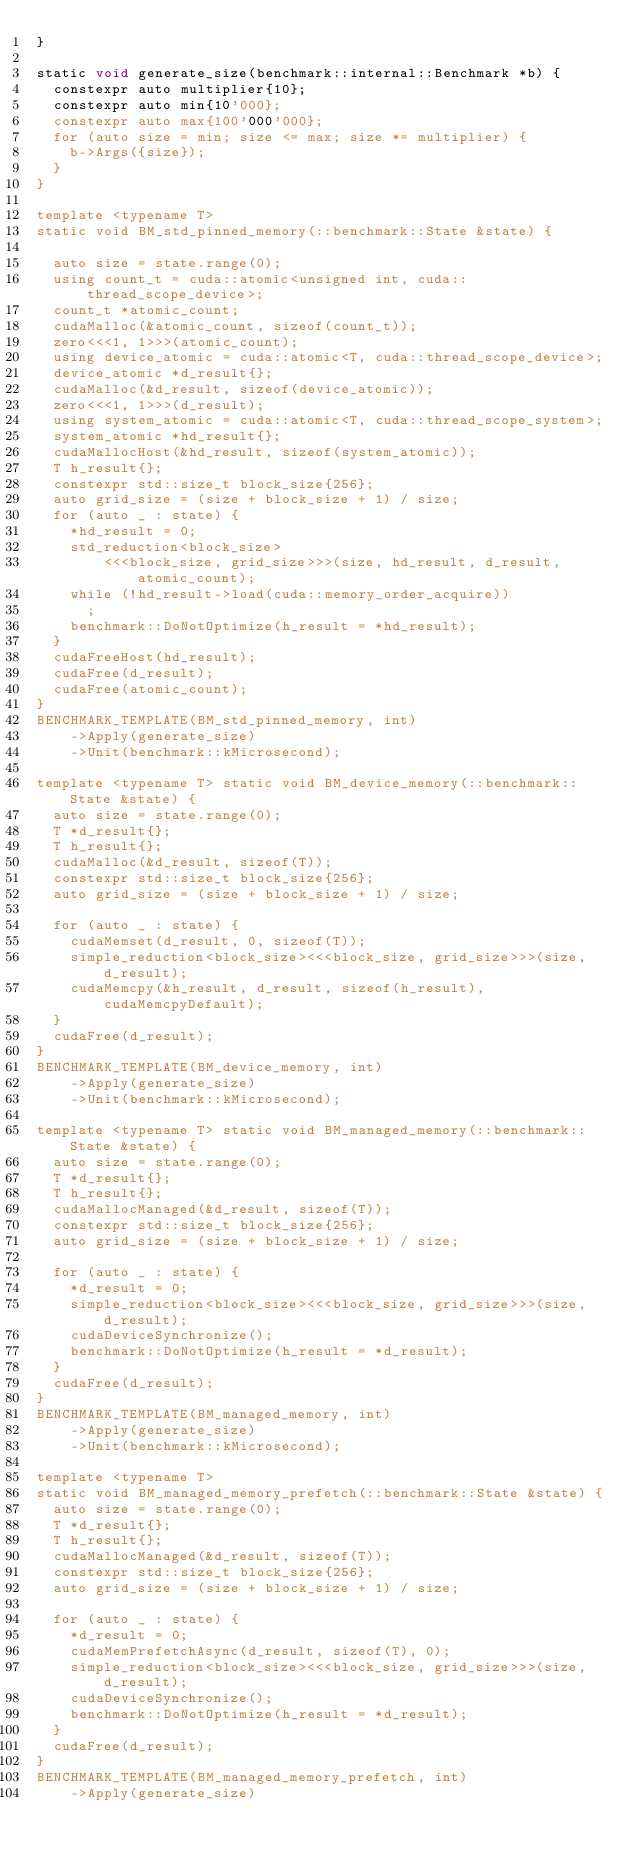Convert code to text. <code><loc_0><loc_0><loc_500><loc_500><_Cuda_>}

static void generate_size(benchmark::internal::Benchmark *b) {
  constexpr auto multiplier{10};
  constexpr auto min{10'000};
  constexpr auto max{100'000'000};
  for (auto size = min; size <= max; size *= multiplier) {
    b->Args({size});
  }
}

template <typename T>
static void BM_std_pinned_memory(::benchmark::State &state) {

  auto size = state.range(0);
  using count_t = cuda::atomic<unsigned int, cuda::thread_scope_device>;
  count_t *atomic_count;
  cudaMalloc(&atomic_count, sizeof(count_t));
  zero<<<1, 1>>>(atomic_count);
  using device_atomic = cuda::atomic<T, cuda::thread_scope_device>;
  device_atomic *d_result{};
  cudaMalloc(&d_result, sizeof(device_atomic));
  zero<<<1, 1>>>(d_result);
  using system_atomic = cuda::atomic<T, cuda::thread_scope_system>;
  system_atomic *hd_result{};
  cudaMallocHost(&hd_result, sizeof(system_atomic));
  T h_result{};
  constexpr std::size_t block_size{256};
  auto grid_size = (size + block_size + 1) / size;
  for (auto _ : state) {
    *hd_result = 0;
    std_reduction<block_size>
        <<<block_size, grid_size>>>(size, hd_result, d_result, atomic_count);
    while (!hd_result->load(cuda::memory_order_acquire))
      ;
    benchmark::DoNotOptimize(h_result = *hd_result);
  }
  cudaFreeHost(hd_result);
  cudaFree(d_result);
  cudaFree(atomic_count);
}
BENCHMARK_TEMPLATE(BM_std_pinned_memory, int)
    ->Apply(generate_size)
    ->Unit(benchmark::kMicrosecond);

template <typename T> static void BM_device_memory(::benchmark::State &state) {
  auto size = state.range(0);
  T *d_result{};
  T h_result{};
  cudaMalloc(&d_result, sizeof(T));
  constexpr std::size_t block_size{256};
  auto grid_size = (size + block_size + 1) / size;

  for (auto _ : state) {
    cudaMemset(d_result, 0, sizeof(T));
    simple_reduction<block_size><<<block_size, grid_size>>>(size, d_result);
    cudaMemcpy(&h_result, d_result, sizeof(h_result), cudaMemcpyDefault);
  }
  cudaFree(d_result);
}
BENCHMARK_TEMPLATE(BM_device_memory, int)
    ->Apply(generate_size)
    ->Unit(benchmark::kMicrosecond);

template <typename T> static void BM_managed_memory(::benchmark::State &state) {
  auto size = state.range(0);
  T *d_result{};
  T h_result{};
  cudaMallocManaged(&d_result, sizeof(T));
  constexpr std::size_t block_size{256};
  auto grid_size = (size + block_size + 1) / size;

  for (auto _ : state) {
    *d_result = 0;
    simple_reduction<block_size><<<block_size, grid_size>>>(size, d_result);
    cudaDeviceSynchronize();
    benchmark::DoNotOptimize(h_result = *d_result);
  }
  cudaFree(d_result);
}
BENCHMARK_TEMPLATE(BM_managed_memory, int)
    ->Apply(generate_size)
    ->Unit(benchmark::kMicrosecond);

template <typename T>
static void BM_managed_memory_prefetch(::benchmark::State &state) {
  auto size = state.range(0);
  T *d_result{};
  T h_result{};
  cudaMallocManaged(&d_result, sizeof(T));
  constexpr std::size_t block_size{256};
  auto grid_size = (size + block_size + 1) / size;

  for (auto _ : state) {
    *d_result = 0;
    cudaMemPrefetchAsync(d_result, sizeof(T), 0);
    simple_reduction<block_size><<<block_size, grid_size>>>(size, d_result);
    cudaDeviceSynchronize();
    benchmark::DoNotOptimize(h_result = *d_result);
  }
  cudaFree(d_result);
}
BENCHMARK_TEMPLATE(BM_managed_memory_prefetch, int)
    ->Apply(generate_size)</code> 